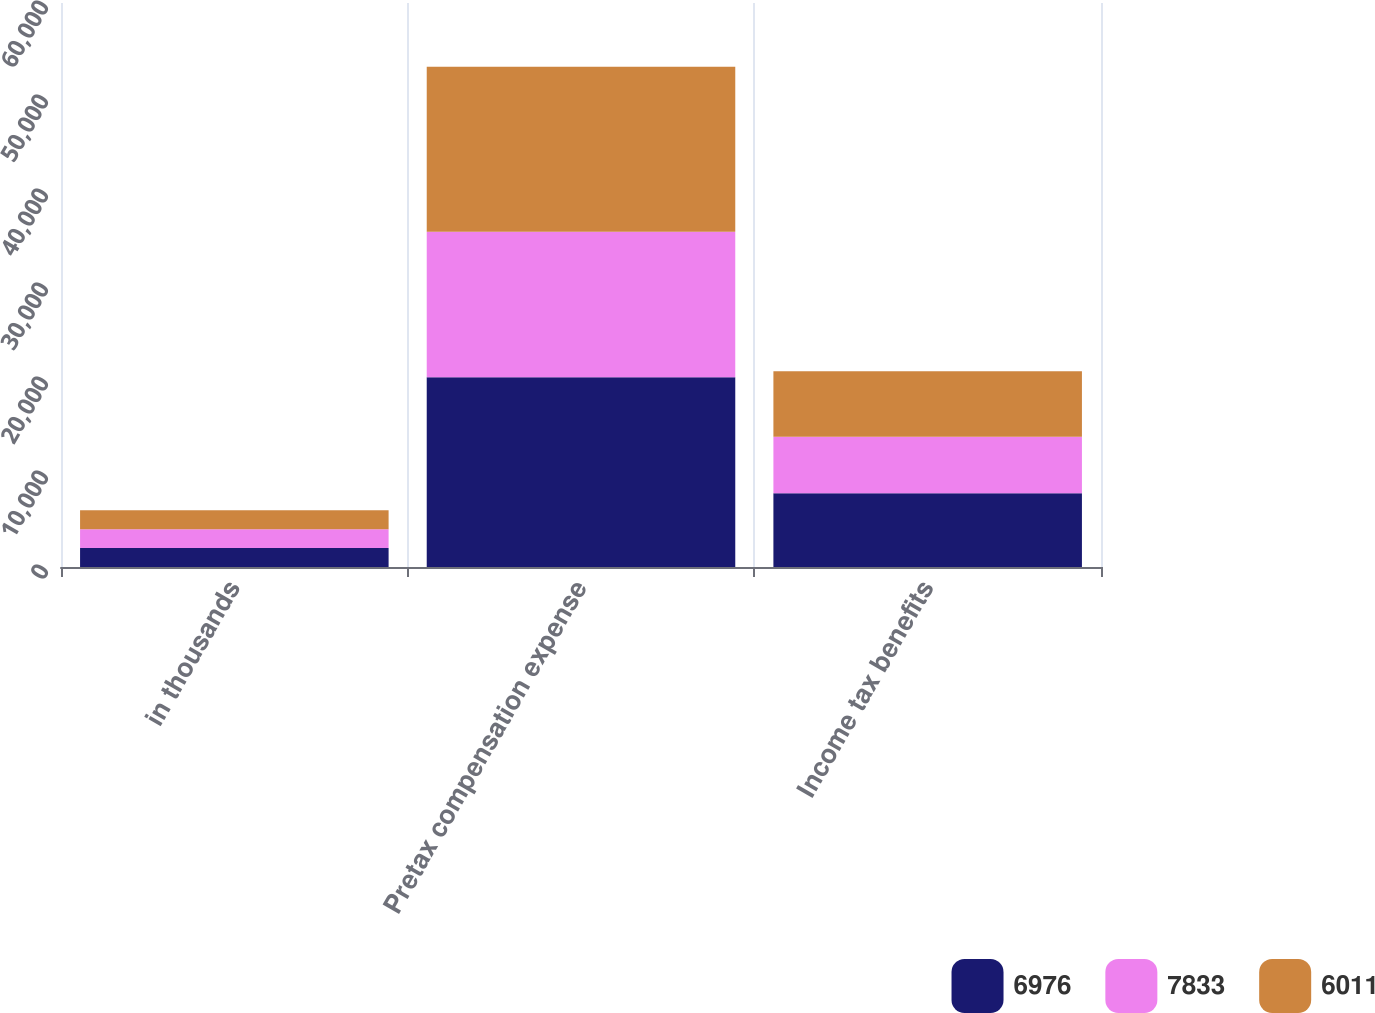Convert chart to OTSL. <chart><loc_0><loc_0><loc_500><loc_500><stacked_bar_chart><ecel><fcel>in thousands<fcel>Pretax compensation expense<fcel>Income tax benefits<nl><fcel>6976<fcel>2013<fcel>20187<fcel>7833<nl><fcel>7833<fcel>2012<fcel>15491<fcel>6011<nl><fcel>6011<fcel>2011<fcel>17537<fcel>6976<nl></chart> 